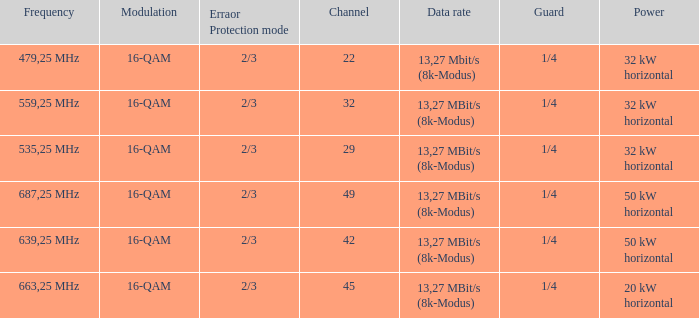On channel 32, when the power is 32 kW horizontal, what is the frequency? 559,25 MHz. 